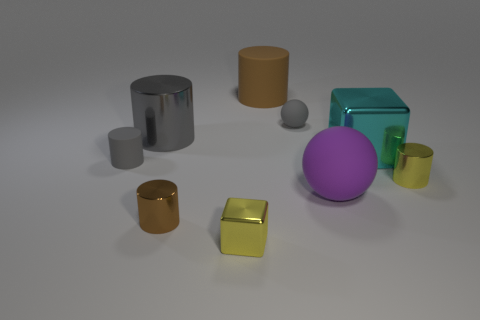In relation to the size of the objects, how would you describe the overall composition? The composition is a balanced arrangement of geometric shapes of varying sizes, creating a visually interesting scene with a mix of symmetry and asymmetry. 